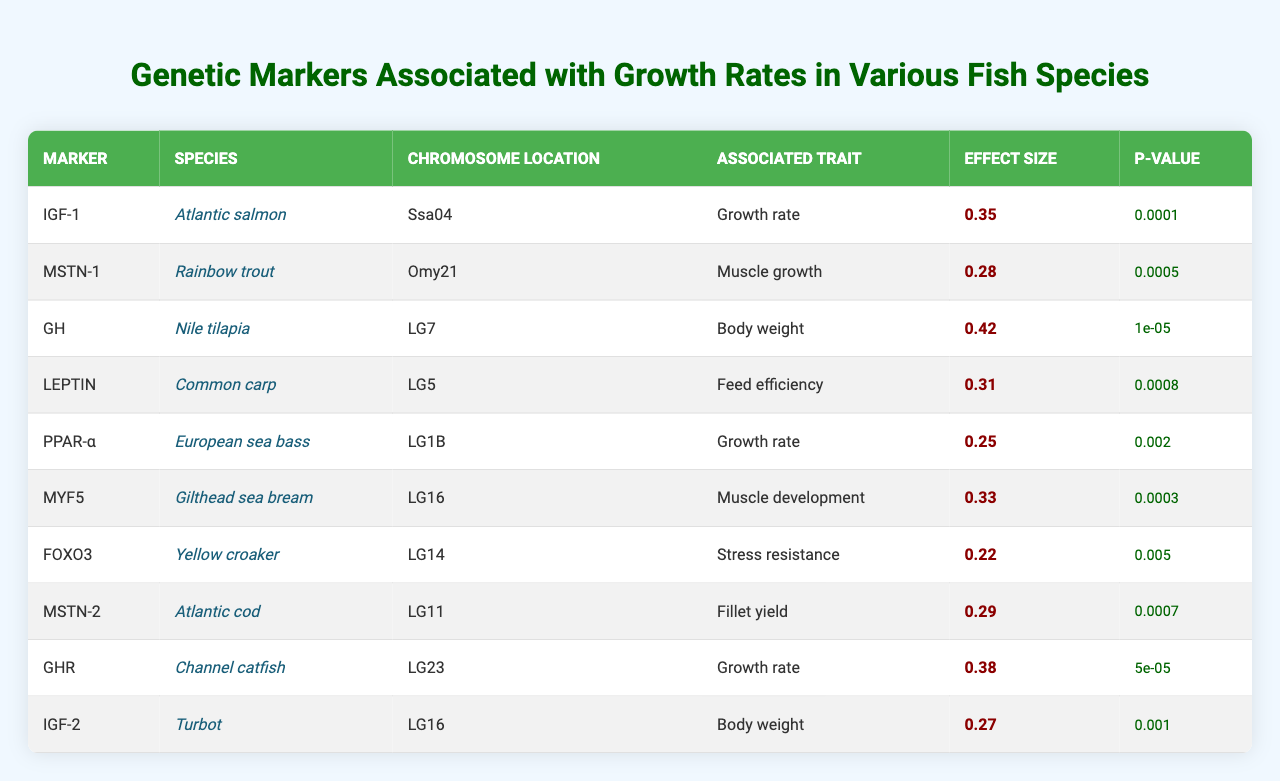What genetic marker is associated with the growth rate in Atlantic salmon? The table lists the genetic marker "IGF-1" as associated with the growth rate for Atlantic salmon.
Answer: IGF-1 Which species has the highest effect size value identified? By examining the effect size values, "GH" in Nile tilapia has the highest effect size at 0.42.
Answer: Nile tilapia Is the p-value for the marker "MSTN-1" less than 0.001? The p-value for "MSTN-1" associated with Rainbow trout is 0.0005, which is indeed less than 0.001.
Answer: Yes What is the average effect size of the markers associated with muscle growth? The effect sizes for muscle growth are 0.28 (MSTN-1) and 0.33 (MYF5), with an average calculated as (0.28 + 0.33) / 2 = 0.305.
Answer: 0.305 Which species has a genetic marker associated with both growth rate and body weight? The table indicates that Nile tilapia has the growth rate associated with the marker "GH" with an effect size of 0.42, while "IGF-2" is associated with body weight, not growth rate. Therefore, there is no species with a marker for both traits.
Answer: No How many markers in the table have p-values less than 0.001? By counting the p-values in the table, we find five markers with p-values below 0.001: IGF-1, GH, and GHR.
Answer: 5 Which markers are associated with muscle development and what are their effect sizes? The markers related to muscle development are "MSTN-1" with an effect size of 0.28 and "MYF5" with an effect size of 0.33.
Answer: MSTN-1 (0.28), MYF5 (0.33) Is there a genetic marker with a p-value greater than 0.005 that is associated with growth rate? The marker "PPAR-α" has a p-value of 0.002, which is less than 0.005, and the marker "FOXO3" has a p-value of 0.005, equal to that amount, and "GHR" with a p-value of 0.00005. The table reveals that all growth rate markers identified have a p-value less than or equal to 0.005.
Answer: No Which chromosome location has the marker with the greatest effect size associated with growth rate? The marker with the greatest effect size associated with growth rate is "GH" located at LG7, with an effect size of 0.42.
Answer: LG7 How many species in total are represented in this table? There are ten different species listed in the table, each corresponding to a unique genetic marker.
Answer: 10 